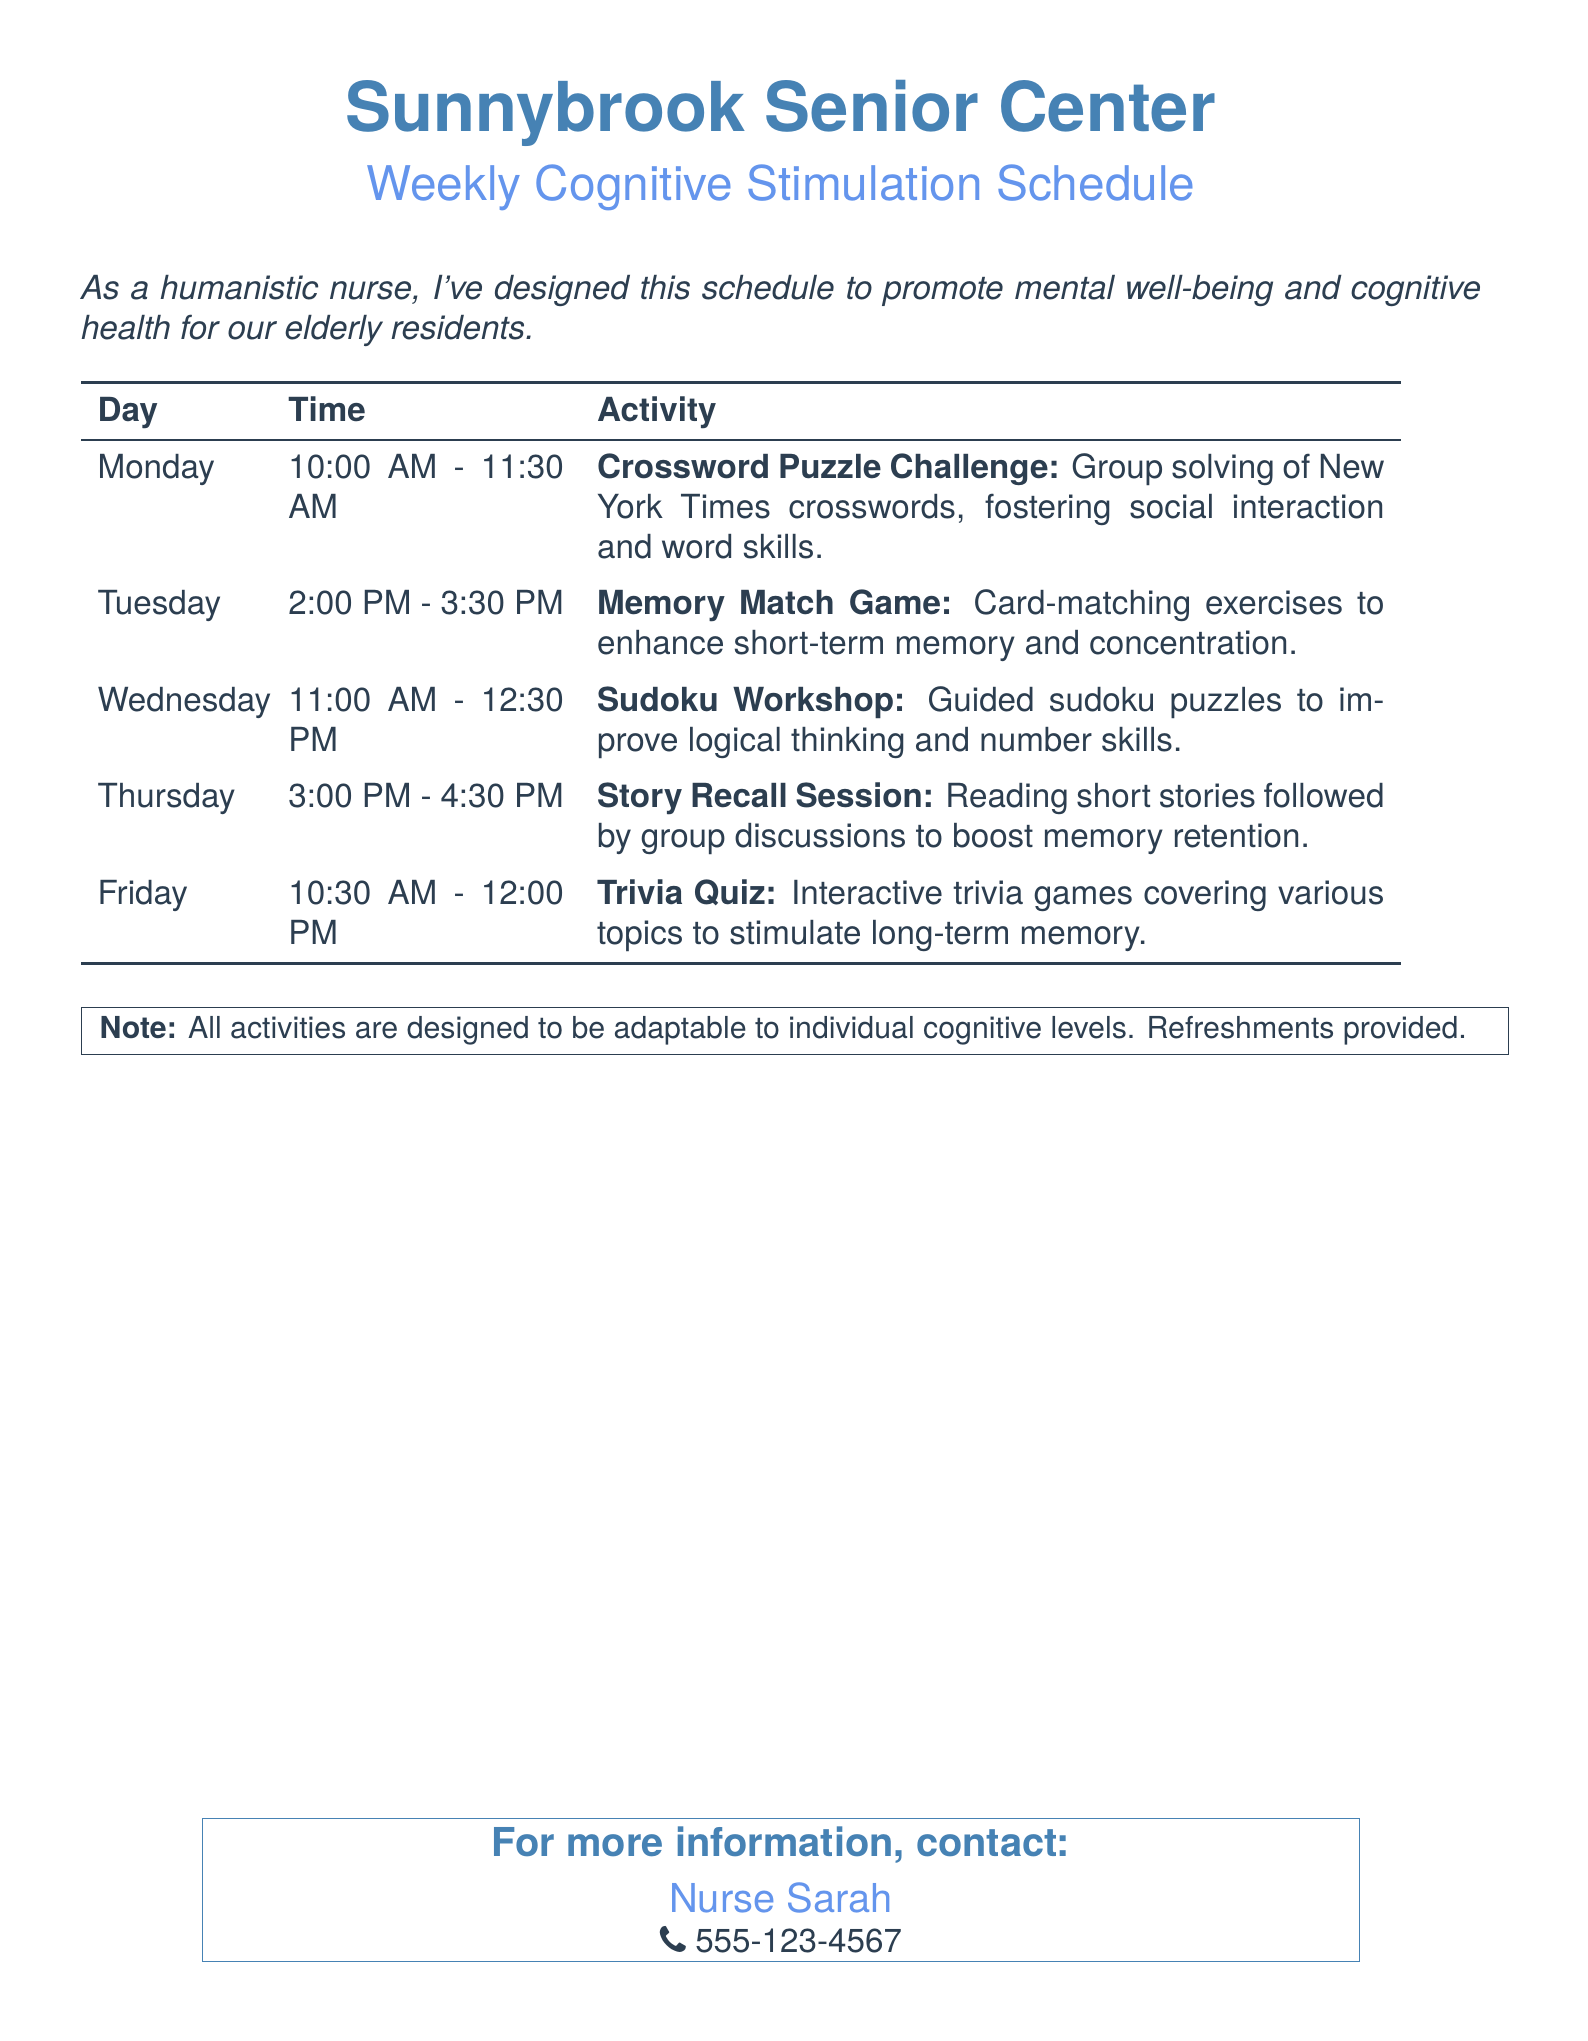What is the name of the center? The document states that the name of the center is mentioned at the top, "Sunnybrook Senior Center."
Answer: Sunnybrook Senior Center What day is the crossword puzzle challenge scheduled? The document lists activities under specific days, and the crossword puzzle challenge is scheduled for Monday.
Answer: Monday What time does the memory match game start? The schedule indicates that the memory match game starts at 2:00 PM on Tuesday.
Answer: 2:00 PM Which activity occurs on Wednesday? The document specifies that the activity scheduled for Wednesday is the Sudoku workshop.
Answer: Sudoku Workshop How long is the trivia quiz session? The document provides the time duration, stating the trivia quiz lasts from 10:30 AM to 12:00 PM on Friday, which is 1.5 hours.
Answer: 1.5 hours What type of game is included on Tuesday? Looking at the schedule, Tuesday features the memory match game as an activity.
Answer: Memory Match Game How are the activities tailored for participants? The document notes that all activities are designed to be adaptable to individual cognitive levels, allowing for customization according to needs.
Answer: Adaptable to individual cognitive levels Who should be contacted for more information? The document specifies that inquiries should be directed to Nurse Sarah for more information about the activities.
Answer: Nurse Sarah What is provided during the activities? The document mentions that refreshments are provided for the participants during the activities.
Answer: Refreshments 